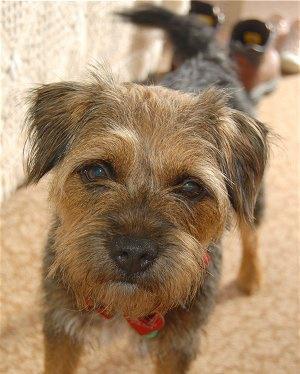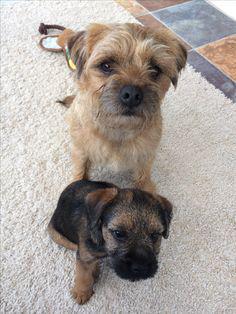The first image is the image on the left, the second image is the image on the right. For the images shown, is this caption "In the image to the right, there is but one dog." true? Answer yes or no. No. 